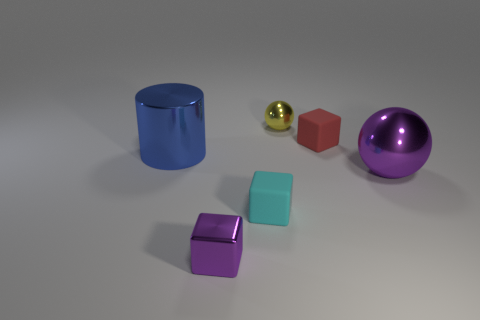There is a shiny object that is the same size as the cylinder; what shape is it?
Provide a succinct answer. Sphere. There is a tiny thing in front of the tiny cyan object that is left of the yellow metal object; are there any yellow shiny spheres right of it?
Offer a terse response. Yes. Are there any purple shiny things of the same size as the cyan matte block?
Keep it short and to the point. Yes. How big is the metal object behind the large blue metal object?
Keep it short and to the point. Small. What is the color of the tiny shiny block that is to the left of the ball behind the big thing that is to the left of the yellow metallic sphere?
Your response must be concise. Purple. What is the color of the metal thing that is on the right side of the tiny shiny thing that is behind the tiny purple shiny thing?
Your answer should be very brief. Purple. Are there more small cyan blocks that are behind the red rubber object than tiny yellow things that are right of the yellow sphere?
Keep it short and to the point. No. Are the block to the left of the small cyan matte thing and the tiny object behind the red block made of the same material?
Offer a terse response. Yes. There is a blue metal object; are there any blue things in front of it?
Offer a very short reply. No. How many red things are large shiny cylinders or big cubes?
Offer a very short reply. 0. 